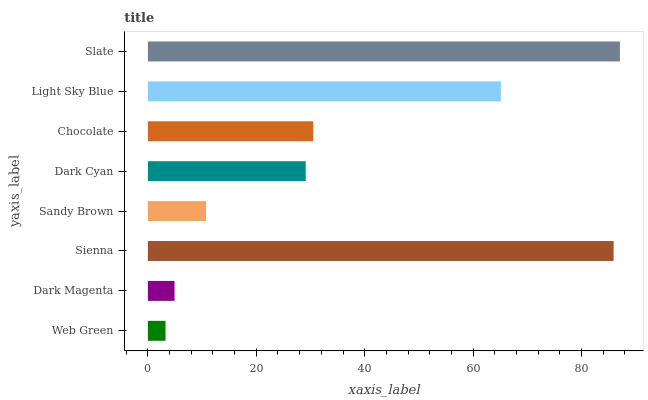Is Web Green the minimum?
Answer yes or no. Yes. Is Slate the maximum?
Answer yes or no. Yes. Is Dark Magenta the minimum?
Answer yes or no. No. Is Dark Magenta the maximum?
Answer yes or no. No. Is Dark Magenta greater than Web Green?
Answer yes or no. Yes. Is Web Green less than Dark Magenta?
Answer yes or no. Yes. Is Web Green greater than Dark Magenta?
Answer yes or no. No. Is Dark Magenta less than Web Green?
Answer yes or no. No. Is Chocolate the high median?
Answer yes or no. Yes. Is Dark Cyan the low median?
Answer yes or no. Yes. Is Dark Cyan the high median?
Answer yes or no. No. Is Web Green the low median?
Answer yes or no. No. 